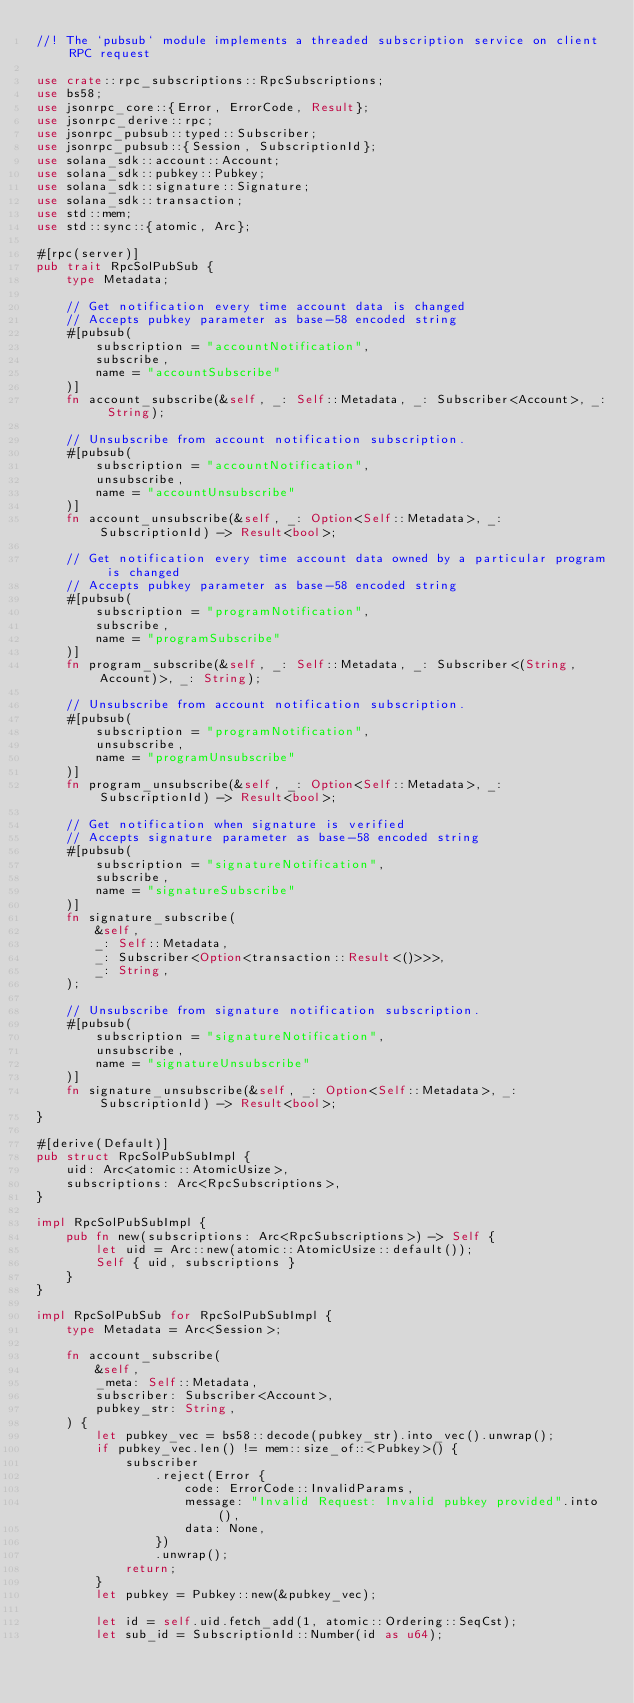Convert code to text. <code><loc_0><loc_0><loc_500><loc_500><_Rust_>//! The `pubsub` module implements a threaded subscription service on client RPC request

use crate::rpc_subscriptions::RpcSubscriptions;
use bs58;
use jsonrpc_core::{Error, ErrorCode, Result};
use jsonrpc_derive::rpc;
use jsonrpc_pubsub::typed::Subscriber;
use jsonrpc_pubsub::{Session, SubscriptionId};
use solana_sdk::account::Account;
use solana_sdk::pubkey::Pubkey;
use solana_sdk::signature::Signature;
use solana_sdk::transaction;
use std::mem;
use std::sync::{atomic, Arc};

#[rpc(server)]
pub trait RpcSolPubSub {
    type Metadata;

    // Get notification every time account data is changed
    // Accepts pubkey parameter as base-58 encoded string
    #[pubsub(
        subscription = "accountNotification",
        subscribe,
        name = "accountSubscribe"
    )]
    fn account_subscribe(&self, _: Self::Metadata, _: Subscriber<Account>, _: String);

    // Unsubscribe from account notification subscription.
    #[pubsub(
        subscription = "accountNotification",
        unsubscribe,
        name = "accountUnsubscribe"
    )]
    fn account_unsubscribe(&self, _: Option<Self::Metadata>, _: SubscriptionId) -> Result<bool>;

    // Get notification every time account data owned by a particular program is changed
    // Accepts pubkey parameter as base-58 encoded string
    #[pubsub(
        subscription = "programNotification",
        subscribe,
        name = "programSubscribe"
    )]
    fn program_subscribe(&self, _: Self::Metadata, _: Subscriber<(String, Account)>, _: String);

    // Unsubscribe from account notification subscription.
    #[pubsub(
        subscription = "programNotification",
        unsubscribe,
        name = "programUnsubscribe"
    )]
    fn program_unsubscribe(&self, _: Option<Self::Metadata>, _: SubscriptionId) -> Result<bool>;

    // Get notification when signature is verified
    // Accepts signature parameter as base-58 encoded string
    #[pubsub(
        subscription = "signatureNotification",
        subscribe,
        name = "signatureSubscribe"
    )]
    fn signature_subscribe(
        &self,
        _: Self::Metadata,
        _: Subscriber<Option<transaction::Result<()>>>,
        _: String,
    );

    // Unsubscribe from signature notification subscription.
    #[pubsub(
        subscription = "signatureNotification",
        unsubscribe,
        name = "signatureUnsubscribe"
    )]
    fn signature_unsubscribe(&self, _: Option<Self::Metadata>, _: SubscriptionId) -> Result<bool>;
}

#[derive(Default)]
pub struct RpcSolPubSubImpl {
    uid: Arc<atomic::AtomicUsize>,
    subscriptions: Arc<RpcSubscriptions>,
}

impl RpcSolPubSubImpl {
    pub fn new(subscriptions: Arc<RpcSubscriptions>) -> Self {
        let uid = Arc::new(atomic::AtomicUsize::default());
        Self { uid, subscriptions }
    }
}

impl RpcSolPubSub for RpcSolPubSubImpl {
    type Metadata = Arc<Session>;

    fn account_subscribe(
        &self,
        _meta: Self::Metadata,
        subscriber: Subscriber<Account>,
        pubkey_str: String,
    ) {
        let pubkey_vec = bs58::decode(pubkey_str).into_vec().unwrap();
        if pubkey_vec.len() != mem::size_of::<Pubkey>() {
            subscriber
                .reject(Error {
                    code: ErrorCode::InvalidParams,
                    message: "Invalid Request: Invalid pubkey provided".into(),
                    data: None,
                })
                .unwrap();
            return;
        }
        let pubkey = Pubkey::new(&pubkey_vec);

        let id = self.uid.fetch_add(1, atomic::Ordering::SeqCst);
        let sub_id = SubscriptionId::Number(id as u64);</code> 